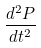<formula> <loc_0><loc_0><loc_500><loc_500>\frac { d ^ { 2 } P } { d t ^ { 2 } }</formula> 